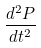<formula> <loc_0><loc_0><loc_500><loc_500>\frac { d ^ { 2 } P } { d t ^ { 2 } }</formula> 